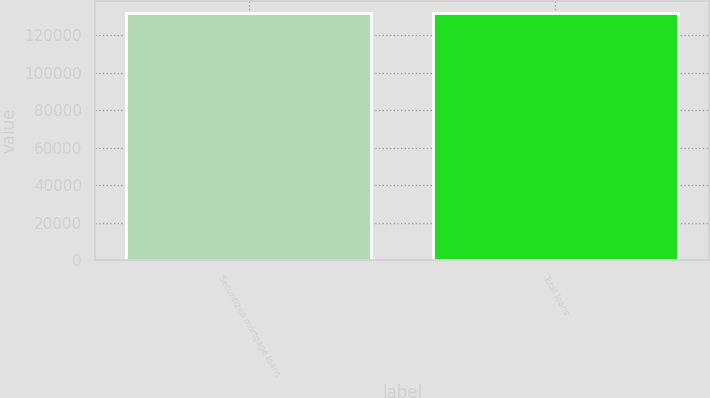Convert chart. <chart><loc_0><loc_0><loc_500><loc_500><bar_chart><fcel>Securitized mortgage loans<fcel>Total loans<nl><fcel>132015<fcel>132015<nl></chart> 